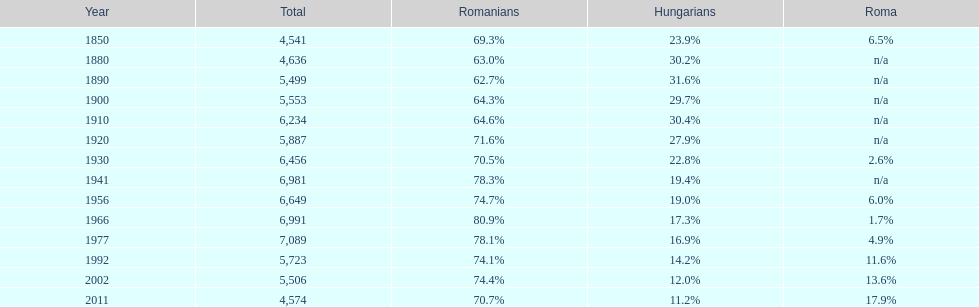How many hungarians were there in the year 1850? 23.9%. 